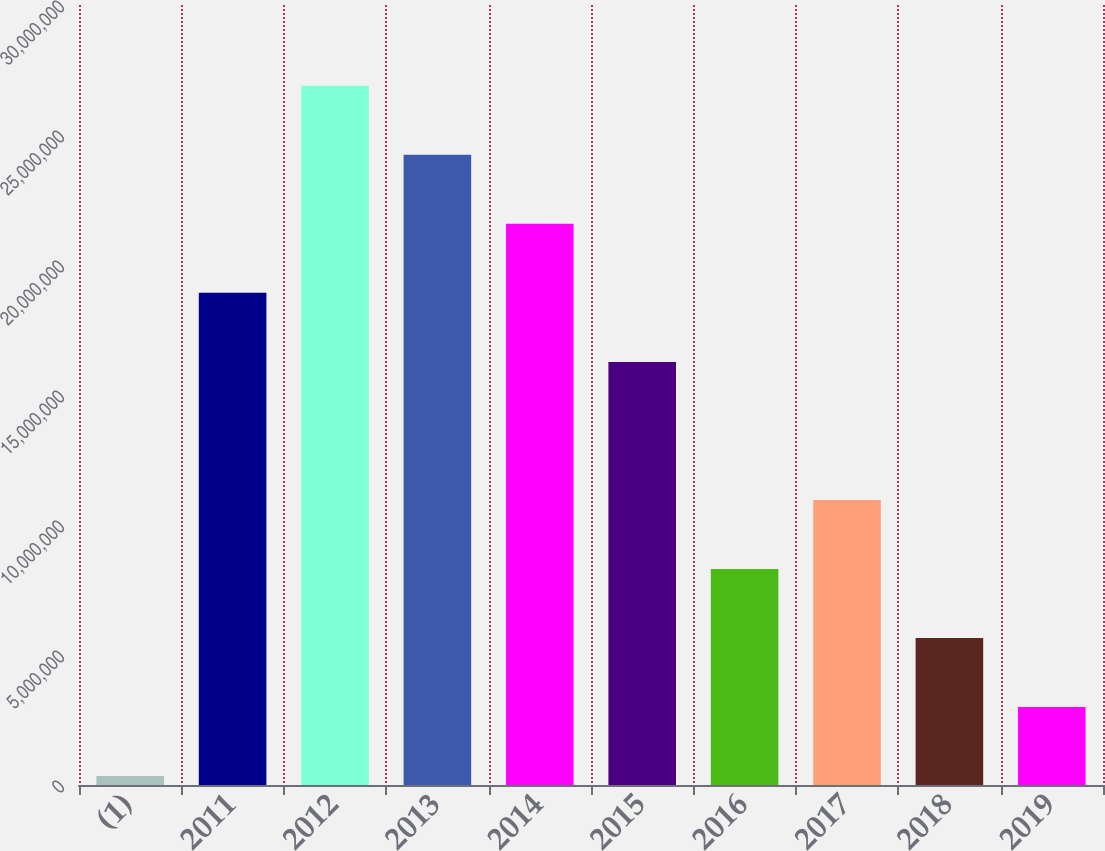Convert chart. <chart><loc_0><loc_0><loc_500><loc_500><bar_chart><fcel>(1)<fcel>2011<fcel>2012<fcel>2013<fcel>2014<fcel>2015<fcel>2016<fcel>2017<fcel>2018<fcel>2019<nl><fcel>347598<fcel>1.8928e+07<fcel>2.6891e+07<fcel>2.42366e+07<fcel>2.15823e+07<fcel>1.62736e+07<fcel>8.31061e+06<fcel>1.0965e+07<fcel>5.65628e+06<fcel>3.00194e+06<nl></chart> 